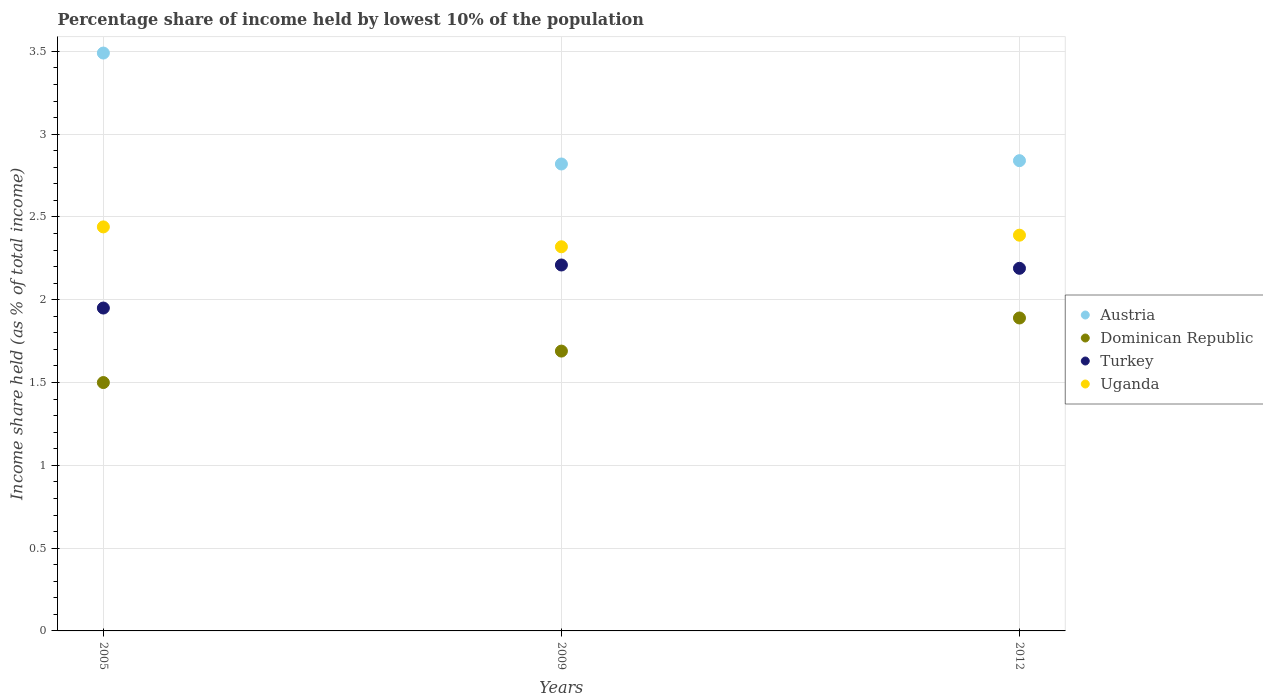How many different coloured dotlines are there?
Your answer should be very brief. 4. What is the percentage share of income held by lowest 10% of the population in Uganda in 2012?
Your response must be concise. 2.39. Across all years, what is the maximum percentage share of income held by lowest 10% of the population in Uganda?
Offer a very short reply. 2.44. Across all years, what is the minimum percentage share of income held by lowest 10% of the population in Turkey?
Offer a very short reply. 1.95. In which year was the percentage share of income held by lowest 10% of the population in Turkey maximum?
Make the answer very short. 2009. What is the total percentage share of income held by lowest 10% of the population in Uganda in the graph?
Make the answer very short. 7.15. What is the difference between the percentage share of income held by lowest 10% of the population in Austria in 2005 and that in 2012?
Ensure brevity in your answer.  0.65. What is the difference between the percentage share of income held by lowest 10% of the population in Uganda in 2009 and the percentage share of income held by lowest 10% of the population in Dominican Republic in 2012?
Your answer should be compact. 0.43. What is the average percentage share of income held by lowest 10% of the population in Dominican Republic per year?
Offer a very short reply. 1.69. In the year 2005, what is the difference between the percentage share of income held by lowest 10% of the population in Austria and percentage share of income held by lowest 10% of the population in Uganda?
Provide a succinct answer. 1.05. In how many years, is the percentage share of income held by lowest 10% of the population in Turkey greater than 0.30000000000000004 %?
Offer a terse response. 3. What is the ratio of the percentage share of income held by lowest 10% of the population in Dominican Republic in 2009 to that in 2012?
Offer a very short reply. 0.89. Is the percentage share of income held by lowest 10% of the population in Turkey in 2005 less than that in 2012?
Give a very brief answer. Yes. Is the difference between the percentage share of income held by lowest 10% of the population in Austria in 2009 and 2012 greater than the difference between the percentage share of income held by lowest 10% of the population in Uganda in 2009 and 2012?
Offer a very short reply. Yes. What is the difference between the highest and the second highest percentage share of income held by lowest 10% of the population in Dominican Republic?
Provide a succinct answer. 0.2. What is the difference between the highest and the lowest percentage share of income held by lowest 10% of the population in Turkey?
Offer a very short reply. 0.26. Is it the case that in every year, the sum of the percentage share of income held by lowest 10% of the population in Turkey and percentage share of income held by lowest 10% of the population in Austria  is greater than the percentage share of income held by lowest 10% of the population in Dominican Republic?
Offer a terse response. Yes. How many years are there in the graph?
Ensure brevity in your answer.  3. Are the values on the major ticks of Y-axis written in scientific E-notation?
Offer a very short reply. No. How are the legend labels stacked?
Offer a terse response. Vertical. What is the title of the graph?
Your answer should be compact. Percentage share of income held by lowest 10% of the population. Does "Djibouti" appear as one of the legend labels in the graph?
Your response must be concise. No. What is the label or title of the X-axis?
Keep it short and to the point. Years. What is the label or title of the Y-axis?
Ensure brevity in your answer.  Income share held (as % of total income). What is the Income share held (as % of total income) of Austria in 2005?
Provide a short and direct response. 3.49. What is the Income share held (as % of total income) in Turkey in 2005?
Make the answer very short. 1.95. What is the Income share held (as % of total income) in Uganda in 2005?
Your response must be concise. 2.44. What is the Income share held (as % of total income) in Austria in 2009?
Ensure brevity in your answer.  2.82. What is the Income share held (as % of total income) of Dominican Republic in 2009?
Ensure brevity in your answer.  1.69. What is the Income share held (as % of total income) in Turkey in 2009?
Your response must be concise. 2.21. What is the Income share held (as % of total income) in Uganda in 2009?
Ensure brevity in your answer.  2.32. What is the Income share held (as % of total income) in Austria in 2012?
Provide a short and direct response. 2.84. What is the Income share held (as % of total income) in Dominican Republic in 2012?
Make the answer very short. 1.89. What is the Income share held (as % of total income) in Turkey in 2012?
Provide a succinct answer. 2.19. What is the Income share held (as % of total income) of Uganda in 2012?
Your response must be concise. 2.39. Across all years, what is the maximum Income share held (as % of total income) of Austria?
Make the answer very short. 3.49. Across all years, what is the maximum Income share held (as % of total income) of Dominican Republic?
Your answer should be very brief. 1.89. Across all years, what is the maximum Income share held (as % of total income) in Turkey?
Offer a very short reply. 2.21. Across all years, what is the maximum Income share held (as % of total income) in Uganda?
Give a very brief answer. 2.44. Across all years, what is the minimum Income share held (as % of total income) in Austria?
Make the answer very short. 2.82. Across all years, what is the minimum Income share held (as % of total income) of Dominican Republic?
Provide a succinct answer. 1.5. Across all years, what is the minimum Income share held (as % of total income) in Turkey?
Your response must be concise. 1.95. Across all years, what is the minimum Income share held (as % of total income) of Uganda?
Keep it short and to the point. 2.32. What is the total Income share held (as % of total income) of Austria in the graph?
Provide a short and direct response. 9.15. What is the total Income share held (as % of total income) of Dominican Republic in the graph?
Offer a very short reply. 5.08. What is the total Income share held (as % of total income) in Turkey in the graph?
Ensure brevity in your answer.  6.35. What is the total Income share held (as % of total income) in Uganda in the graph?
Offer a terse response. 7.15. What is the difference between the Income share held (as % of total income) in Austria in 2005 and that in 2009?
Provide a short and direct response. 0.67. What is the difference between the Income share held (as % of total income) of Dominican Republic in 2005 and that in 2009?
Keep it short and to the point. -0.19. What is the difference between the Income share held (as % of total income) in Turkey in 2005 and that in 2009?
Keep it short and to the point. -0.26. What is the difference between the Income share held (as % of total income) in Uganda in 2005 and that in 2009?
Your response must be concise. 0.12. What is the difference between the Income share held (as % of total income) of Austria in 2005 and that in 2012?
Keep it short and to the point. 0.65. What is the difference between the Income share held (as % of total income) of Dominican Republic in 2005 and that in 2012?
Provide a succinct answer. -0.39. What is the difference between the Income share held (as % of total income) of Turkey in 2005 and that in 2012?
Provide a short and direct response. -0.24. What is the difference between the Income share held (as % of total income) in Uganda in 2005 and that in 2012?
Your response must be concise. 0.05. What is the difference between the Income share held (as % of total income) in Austria in 2009 and that in 2012?
Give a very brief answer. -0.02. What is the difference between the Income share held (as % of total income) of Dominican Republic in 2009 and that in 2012?
Ensure brevity in your answer.  -0.2. What is the difference between the Income share held (as % of total income) of Turkey in 2009 and that in 2012?
Make the answer very short. 0.02. What is the difference between the Income share held (as % of total income) in Uganda in 2009 and that in 2012?
Offer a terse response. -0.07. What is the difference between the Income share held (as % of total income) in Austria in 2005 and the Income share held (as % of total income) in Dominican Republic in 2009?
Provide a short and direct response. 1.8. What is the difference between the Income share held (as % of total income) of Austria in 2005 and the Income share held (as % of total income) of Turkey in 2009?
Your answer should be very brief. 1.28. What is the difference between the Income share held (as % of total income) in Austria in 2005 and the Income share held (as % of total income) in Uganda in 2009?
Offer a terse response. 1.17. What is the difference between the Income share held (as % of total income) in Dominican Republic in 2005 and the Income share held (as % of total income) in Turkey in 2009?
Keep it short and to the point. -0.71. What is the difference between the Income share held (as % of total income) of Dominican Republic in 2005 and the Income share held (as % of total income) of Uganda in 2009?
Make the answer very short. -0.82. What is the difference between the Income share held (as % of total income) in Turkey in 2005 and the Income share held (as % of total income) in Uganda in 2009?
Make the answer very short. -0.37. What is the difference between the Income share held (as % of total income) in Austria in 2005 and the Income share held (as % of total income) in Uganda in 2012?
Your answer should be compact. 1.1. What is the difference between the Income share held (as % of total income) in Dominican Republic in 2005 and the Income share held (as % of total income) in Turkey in 2012?
Keep it short and to the point. -0.69. What is the difference between the Income share held (as % of total income) in Dominican Republic in 2005 and the Income share held (as % of total income) in Uganda in 2012?
Your response must be concise. -0.89. What is the difference between the Income share held (as % of total income) of Turkey in 2005 and the Income share held (as % of total income) of Uganda in 2012?
Make the answer very short. -0.44. What is the difference between the Income share held (as % of total income) of Austria in 2009 and the Income share held (as % of total income) of Turkey in 2012?
Offer a very short reply. 0.63. What is the difference between the Income share held (as % of total income) of Austria in 2009 and the Income share held (as % of total income) of Uganda in 2012?
Give a very brief answer. 0.43. What is the difference between the Income share held (as % of total income) in Turkey in 2009 and the Income share held (as % of total income) in Uganda in 2012?
Make the answer very short. -0.18. What is the average Income share held (as % of total income) of Austria per year?
Provide a succinct answer. 3.05. What is the average Income share held (as % of total income) of Dominican Republic per year?
Your answer should be very brief. 1.69. What is the average Income share held (as % of total income) in Turkey per year?
Your answer should be very brief. 2.12. What is the average Income share held (as % of total income) of Uganda per year?
Your answer should be compact. 2.38. In the year 2005, what is the difference between the Income share held (as % of total income) in Austria and Income share held (as % of total income) in Dominican Republic?
Provide a succinct answer. 1.99. In the year 2005, what is the difference between the Income share held (as % of total income) in Austria and Income share held (as % of total income) in Turkey?
Provide a succinct answer. 1.54. In the year 2005, what is the difference between the Income share held (as % of total income) in Austria and Income share held (as % of total income) in Uganda?
Keep it short and to the point. 1.05. In the year 2005, what is the difference between the Income share held (as % of total income) of Dominican Republic and Income share held (as % of total income) of Turkey?
Provide a short and direct response. -0.45. In the year 2005, what is the difference between the Income share held (as % of total income) in Dominican Republic and Income share held (as % of total income) in Uganda?
Keep it short and to the point. -0.94. In the year 2005, what is the difference between the Income share held (as % of total income) of Turkey and Income share held (as % of total income) of Uganda?
Offer a terse response. -0.49. In the year 2009, what is the difference between the Income share held (as % of total income) in Austria and Income share held (as % of total income) in Dominican Republic?
Provide a succinct answer. 1.13. In the year 2009, what is the difference between the Income share held (as % of total income) of Austria and Income share held (as % of total income) of Turkey?
Make the answer very short. 0.61. In the year 2009, what is the difference between the Income share held (as % of total income) in Austria and Income share held (as % of total income) in Uganda?
Your answer should be compact. 0.5. In the year 2009, what is the difference between the Income share held (as % of total income) of Dominican Republic and Income share held (as % of total income) of Turkey?
Your response must be concise. -0.52. In the year 2009, what is the difference between the Income share held (as % of total income) of Dominican Republic and Income share held (as % of total income) of Uganda?
Keep it short and to the point. -0.63. In the year 2009, what is the difference between the Income share held (as % of total income) of Turkey and Income share held (as % of total income) of Uganda?
Your response must be concise. -0.11. In the year 2012, what is the difference between the Income share held (as % of total income) in Austria and Income share held (as % of total income) in Dominican Republic?
Keep it short and to the point. 0.95. In the year 2012, what is the difference between the Income share held (as % of total income) of Austria and Income share held (as % of total income) of Turkey?
Give a very brief answer. 0.65. In the year 2012, what is the difference between the Income share held (as % of total income) in Austria and Income share held (as % of total income) in Uganda?
Give a very brief answer. 0.45. In the year 2012, what is the difference between the Income share held (as % of total income) of Turkey and Income share held (as % of total income) of Uganda?
Ensure brevity in your answer.  -0.2. What is the ratio of the Income share held (as % of total income) in Austria in 2005 to that in 2009?
Give a very brief answer. 1.24. What is the ratio of the Income share held (as % of total income) in Dominican Republic in 2005 to that in 2009?
Provide a succinct answer. 0.89. What is the ratio of the Income share held (as % of total income) in Turkey in 2005 to that in 2009?
Your answer should be compact. 0.88. What is the ratio of the Income share held (as % of total income) of Uganda in 2005 to that in 2009?
Ensure brevity in your answer.  1.05. What is the ratio of the Income share held (as % of total income) of Austria in 2005 to that in 2012?
Offer a very short reply. 1.23. What is the ratio of the Income share held (as % of total income) of Dominican Republic in 2005 to that in 2012?
Offer a terse response. 0.79. What is the ratio of the Income share held (as % of total income) of Turkey in 2005 to that in 2012?
Make the answer very short. 0.89. What is the ratio of the Income share held (as % of total income) of Uganda in 2005 to that in 2012?
Give a very brief answer. 1.02. What is the ratio of the Income share held (as % of total income) in Dominican Republic in 2009 to that in 2012?
Provide a succinct answer. 0.89. What is the ratio of the Income share held (as % of total income) of Turkey in 2009 to that in 2012?
Your response must be concise. 1.01. What is the ratio of the Income share held (as % of total income) of Uganda in 2009 to that in 2012?
Your answer should be very brief. 0.97. What is the difference between the highest and the second highest Income share held (as % of total income) in Austria?
Provide a succinct answer. 0.65. What is the difference between the highest and the second highest Income share held (as % of total income) of Uganda?
Your response must be concise. 0.05. What is the difference between the highest and the lowest Income share held (as % of total income) in Austria?
Offer a terse response. 0.67. What is the difference between the highest and the lowest Income share held (as % of total income) of Dominican Republic?
Provide a short and direct response. 0.39. What is the difference between the highest and the lowest Income share held (as % of total income) in Turkey?
Make the answer very short. 0.26. What is the difference between the highest and the lowest Income share held (as % of total income) in Uganda?
Your response must be concise. 0.12. 